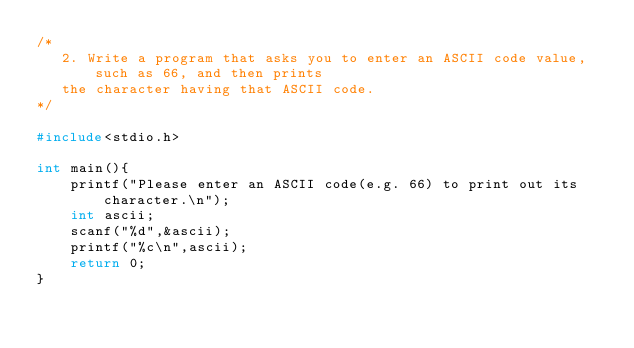Convert code to text. <code><loc_0><loc_0><loc_500><loc_500><_C_>/* 
   2. Write a program that asks you to enter an ASCII code value, such as 66, and then prints
   the character having that ASCII code.
*/

#include<stdio.h>

int main(){
    printf("Please enter an ASCII code(e.g. 66) to print out its character.\n");
    int ascii;
    scanf("%d",&ascii);
    printf("%c\n",ascii);
    return 0;
} </code> 